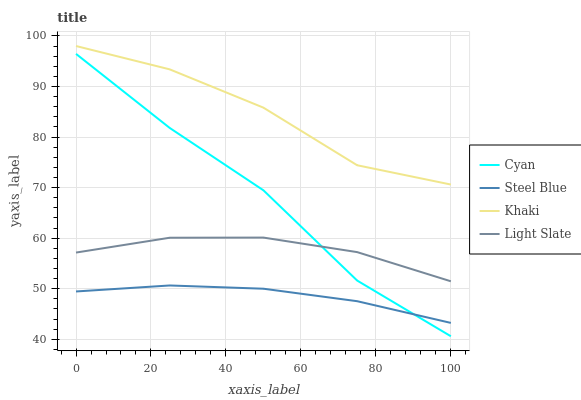Does Steel Blue have the minimum area under the curve?
Answer yes or no. Yes. Does Khaki have the maximum area under the curve?
Answer yes or no. Yes. Does Cyan have the minimum area under the curve?
Answer yes or no. No. Does Cyan have the maximum area under the curve?
Answer yes or no. No. Is Steel Blue the smoothest?
Answer yes or no. Yes. Is Cyan the roughest?
Answer yes or no. Yes. Is Khaki the smoothest?
Answer yes or no. No. Is Khaki the roughest?
Answer yes or no. No. Does Cyan have the lowest value?
Answer yes or no. Yes. Does Khaki have the lowest value?
Answer yes or no. No. Does Khaki have the highest value?
Answer yes or no. Yes. Does Cyan have the highest value?
Answer yes or no. No. Is Steel Blue less than Khaki?
Answer yes or no. Yes. Is Khaki greater than Steel Blue?
Answer yes or no. Yes. Does Cyan intersect Light Slate?
Answer yes or no. Yes. Is Cyan less than Light Slate?
Answer yes or no. No. Is Cyan greater than Light Slate?
Answer yes or no. No. Does Steel Blue intersect Khaki?
Answer yes or no. No. 